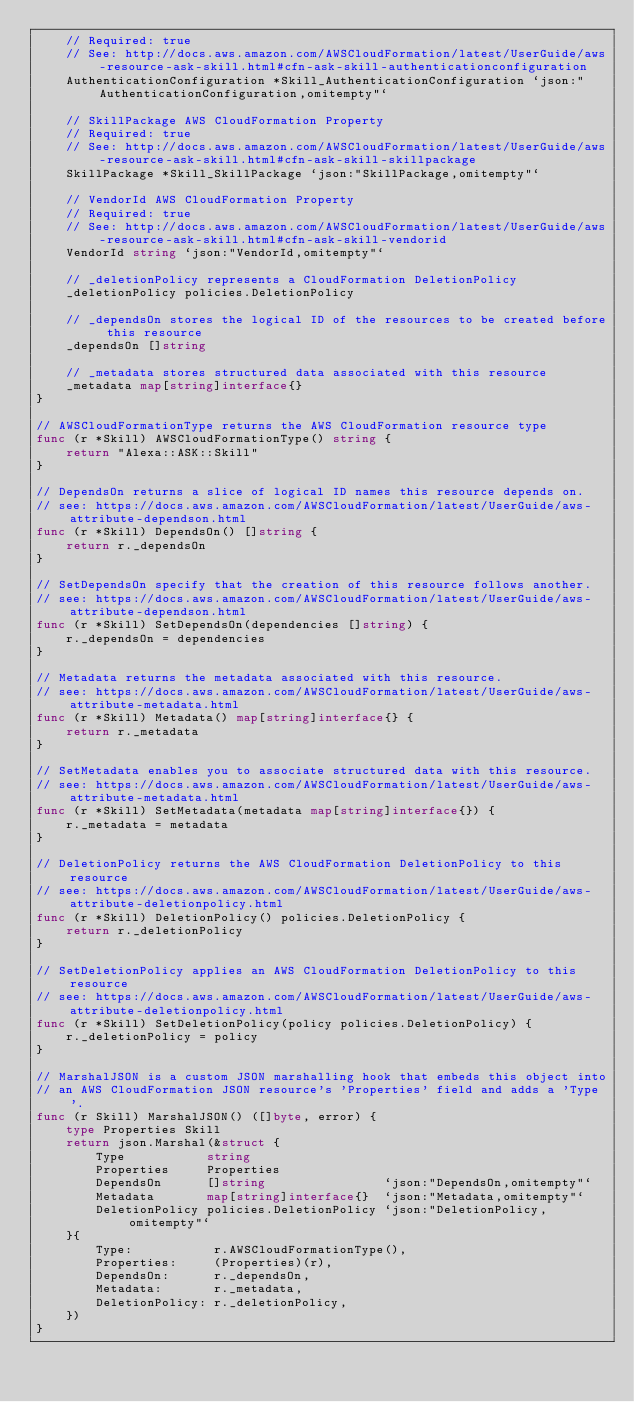<code> <loc_0><loc_0><loc_500><loc_500><_Go_>	// Required: true
	// See: http://docs.aws.amazon.com/AWSCloudFormation/latest/UserGuide/aws-resource-ask-skill.html#cfn-ask-skill-authenticationconfiguration
	AuthenticationConfiguration *Skill_AuthenticationConfiguration `json:"AuthenticationConfiguration,omitempty"`

	// SkillPackage AWS CloudFormation Property
	// Required: true
	// See: http://docs.aws.amazon.com/AWSCloudFormation/latest/UserGuide/aws-resource-ask-skill.html#cfn-ask-skill-skillpackage
	SkillPackage *Skill_SkillPackage `json:"SkillPackage,omitempty"`

	// VendorId AWS CloudFormation Property
	// Required: true
	// See: http://docs.aws.amazon.com/AWSCloudFormation/latest/UserGuide/aws-resource-ask-skill.html#cfn-ask-skill-vendorid
	VendorId string `json:"VendorId,omitempty"`

	// _deletionPolicy represents a CloudFormation DeletionPolicy
	_deletionPolicy policies.DeletionPolicy

	// _dependsOn stores the logical ID of the resources to be created before this resource
	_dependsOn []string

	// _metadata stores structured data associated with this resource
	_metadata map[string]interface{}
}

// AWSCloudFormationType returns the AWS CloudFormation resource type
func (r *Skill) AWSCloudFormationType() string {
	return "Alexa::ASK::Skill"
}

// DependsOn returns a slice of logical ID names this resource depends on.
// see: https://docs.aws.amazon.com/AWSCloudFormation/latest/UserGuide/aws-attribute-dependson.html
func (r *Skill) DependsOn() []string {
	return r._dependsOn
}

// SetDependsOn specify that the creation of this resource follows another.
// see: https://docs.aws.amazon.com/AWSCloudFormation/latest/UserGuide/aws-attribute-dependson.html
func (r *Skill) SetDependsOn(dependencies []string) {
	r._dependsOn = dependencies
}

// Metadata returns the metadata associated with this resource.
// see: https://docs.aws.amazon.com/AWSCloudFormation/latest/UserGuide/aws-attribute-metadata.html
func (r *Skill) Metadata() map[string]interface{} {
	return r._metadata
}

// SetMetadata enables you to associate structured data with this resource.
// see: https://docs.aws.amazon.com/AWSCloudFormation/latest/UserGuide/aws-attribute-metadata.html
func (r *Skill) SetMetadata(metadata map[string]interface{}) {
	r._metadata = metadata
}

// DeletionPolicy returns the AWS CloudFormation DeletionPolicy to this resource
// see: https://docs.aws.amazon.com/AWSCloudFormation/latest/UserGuide/aws-attribute-deletionpolicy.html
func (r *Skill) DeletionPolicy() policies.DeletionPolicy {
	return r._deletionPolicy
}

// SetDeletionPolicy applies an AWS CloudFormation DeletionPolicy to this resource
// see: https://docs.aws.amazon.com/AWSCloudFormation/latest/UserGuide/aws-attribute-deletionpolicy.html
func (r *Skill) SetDeletionPolicy(policy policies.DeletionPolicy) {
	r._deletionPolicy = policy
}

// MarshalJSON is a custom JSON marshalling hook that embeds this object into
// an AWS CloudFormation JSON resource's 'Properties' field and adds a 'Type'.
func (r Skill) MarshalJSON() ([]byte, error) {
	type Properties Skill
	return json.Marshal(&struct {
		Type           string
		Properties     Properties
		DependsOn      []string                `json:"DependsOn,omitempty"`
		Metadata       map[string]interface{}  `json:"Metadata,omitempty"`
		DeletionPolicy policies.DeletionPolicy `json:"DeletionPolicy,omitempty"`
	}{
		Type:           r.AWSCloudFormationType(),
		Properties:     (Properties)(r),
		DependsOn:      r._dependsOn,
		Metadata:       r._metadata,
		DeletionPolicy: r._deletionPolicy,
	})
}
</code> 